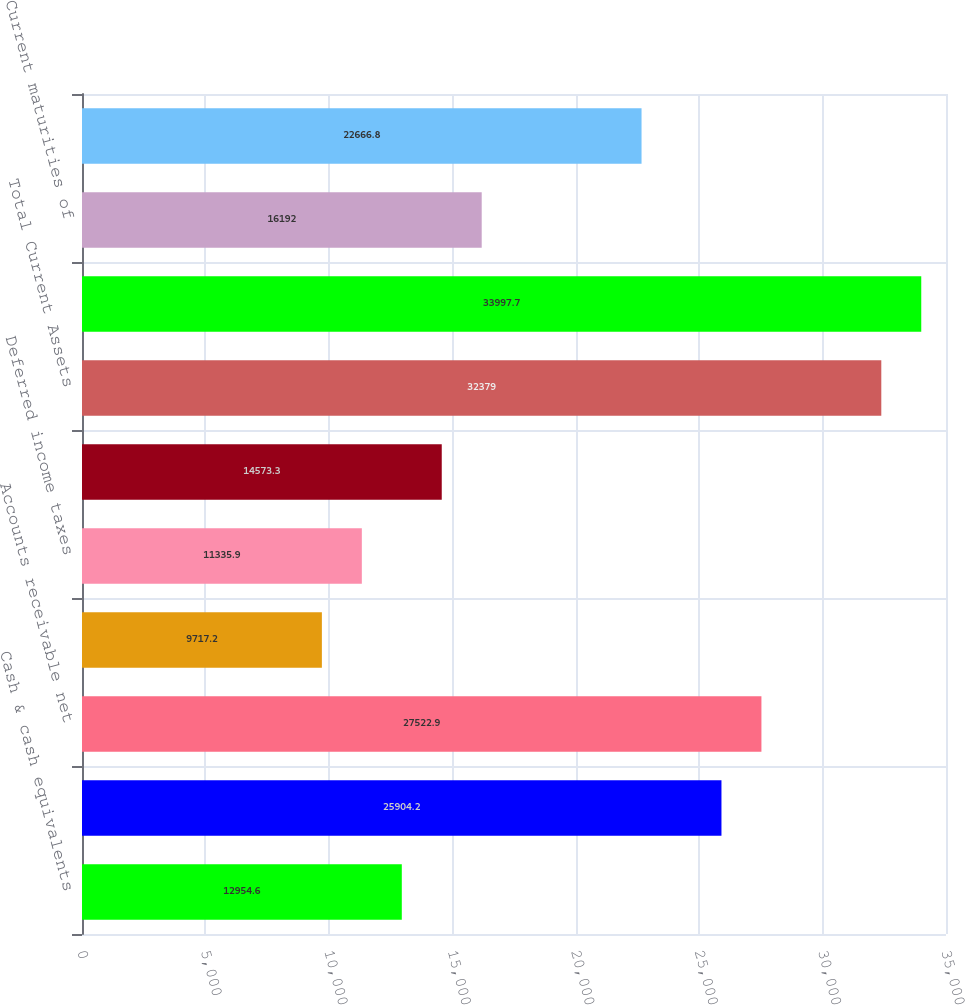Convert chart. <chart><loc_0><loc_0><loc_500><loc_500><bar_chart><fcel>Cash & cash equivalents<fcel>Marketable securities &<fcel>Accounts receivable net<fcel>Income tax receivable<fcel>Deferred income taxes<fcel>Other current assets<fcel>Total Current Assets<fcel>14268 and 13505 in 2005 and<fcel>Current maturities of<fcel>Accounts payable<nl><fcel>12954.6<fcel>25904.2<fcel>27522.9<fcel>9717.2<fcel>11335.9<fcel>14573.3<fcel>32379<fcel>33997.7<fcel>16192<fcel>22666.8<nl></chart> 